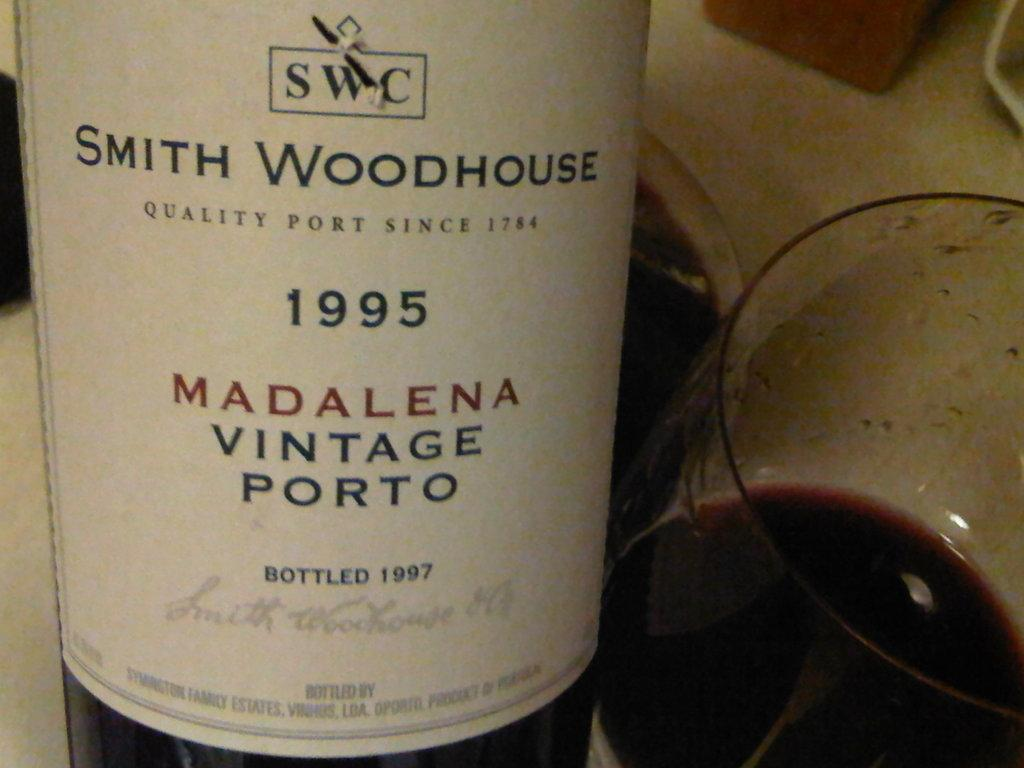<image>
Describe the image concisely. A white logo for smith woodhouse madalena vintage porto with a glass of wine next to it. 